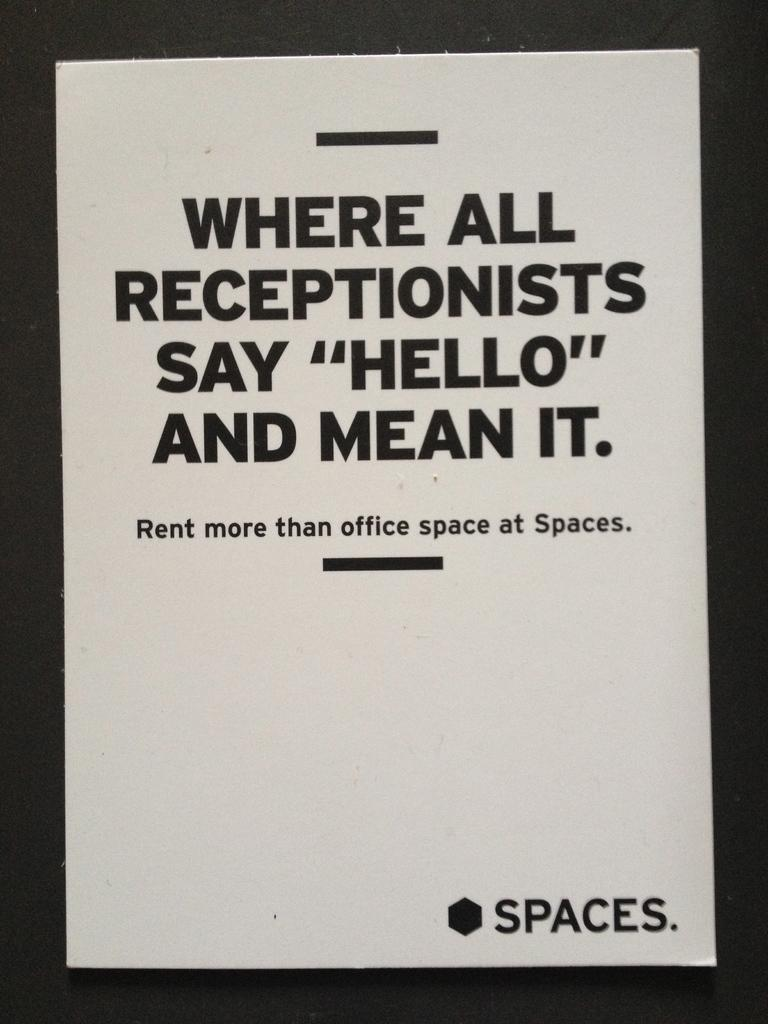What is present in the image that contains information or a message? There is a poster in the image. What can be found on the poster? There is text on the poster. What type of tub is visible in the image? There is no tub present in the image. How is the kite being used in the image? There is no kite present in the image. 